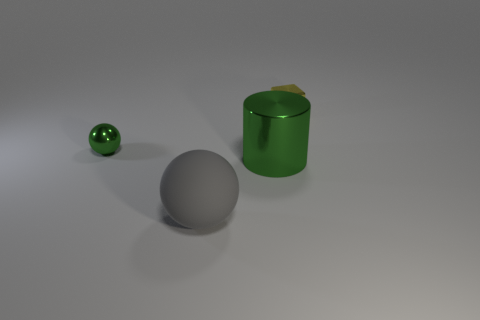Add 2 big green metal cylinders. How many objects exist? 6 Subtract all cylinders. How many objects are left? 3 Add 4 large blue blocks. How many large blue blocks exist? 4 Subtract 0 blue blocks. How many objects are left? 4 Subtract all big cylinders. Subtract all matte objects. How many objects are left? 2 Add 3 small green spheres. How many small green spheres are left? 4 